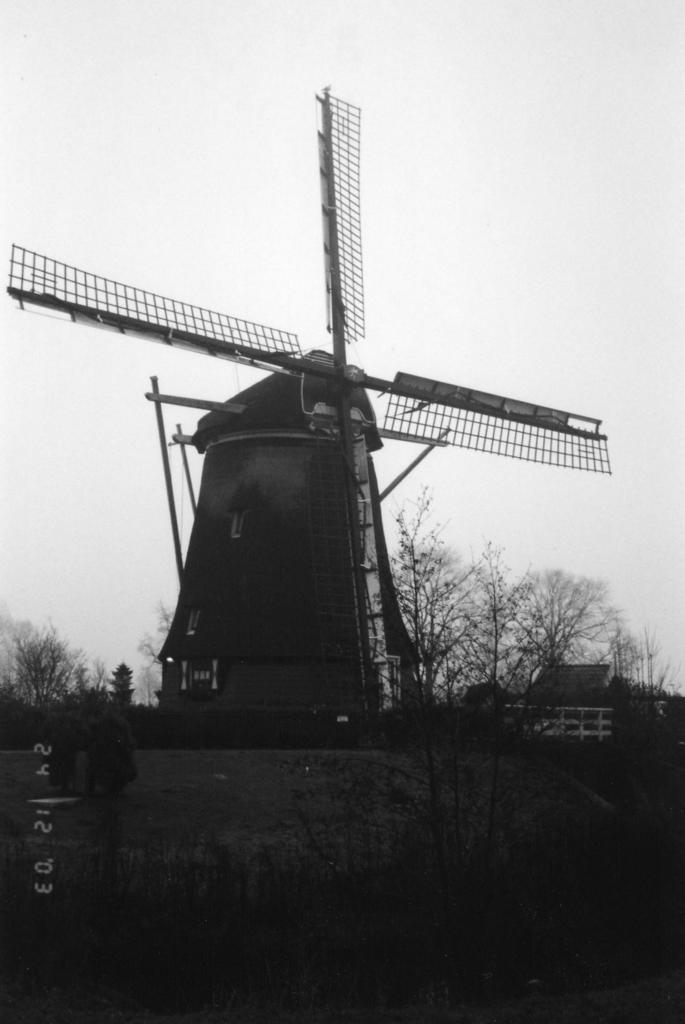What is the color scheme of the image? The image is black and white. What is the main subject in the middle of the image? There is a windmill in the middle of the image. What type of vegetation is at the bottom of the image? There are trees at the bottom of the image. What is visible at the top of the image? The sky is visible at the top of the image. What is the condition of the sky in the image? The sky is cloudy in the image. What type of net is being used to catch the quilt in the image? There is no net or quilt present in the image; it features a windmill, trees, and a cloudy sky. 